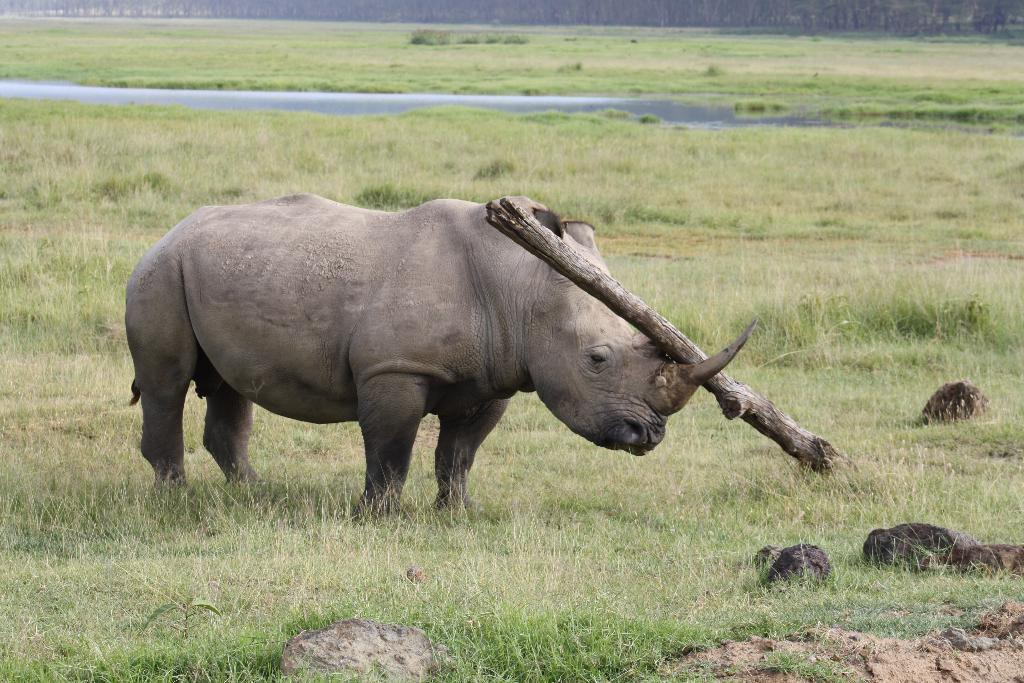What is the main subject in the center of the image? There is a rhinoceros in the center of the image. What else is located in the center of the image? There is a wooden block in the center of the image. What can be seen in the background of the image? Water, grass, and trees are visible in the background of the image. What type of owl can be seen perched on the rhinoceros's back in the image? There is no owl present in the image; the main subject is a rhinoceros and a wooden block. What is the rhinoceros using to secure the wooden block in the image? There is no chain or any other securing mechanism visible in the image. 